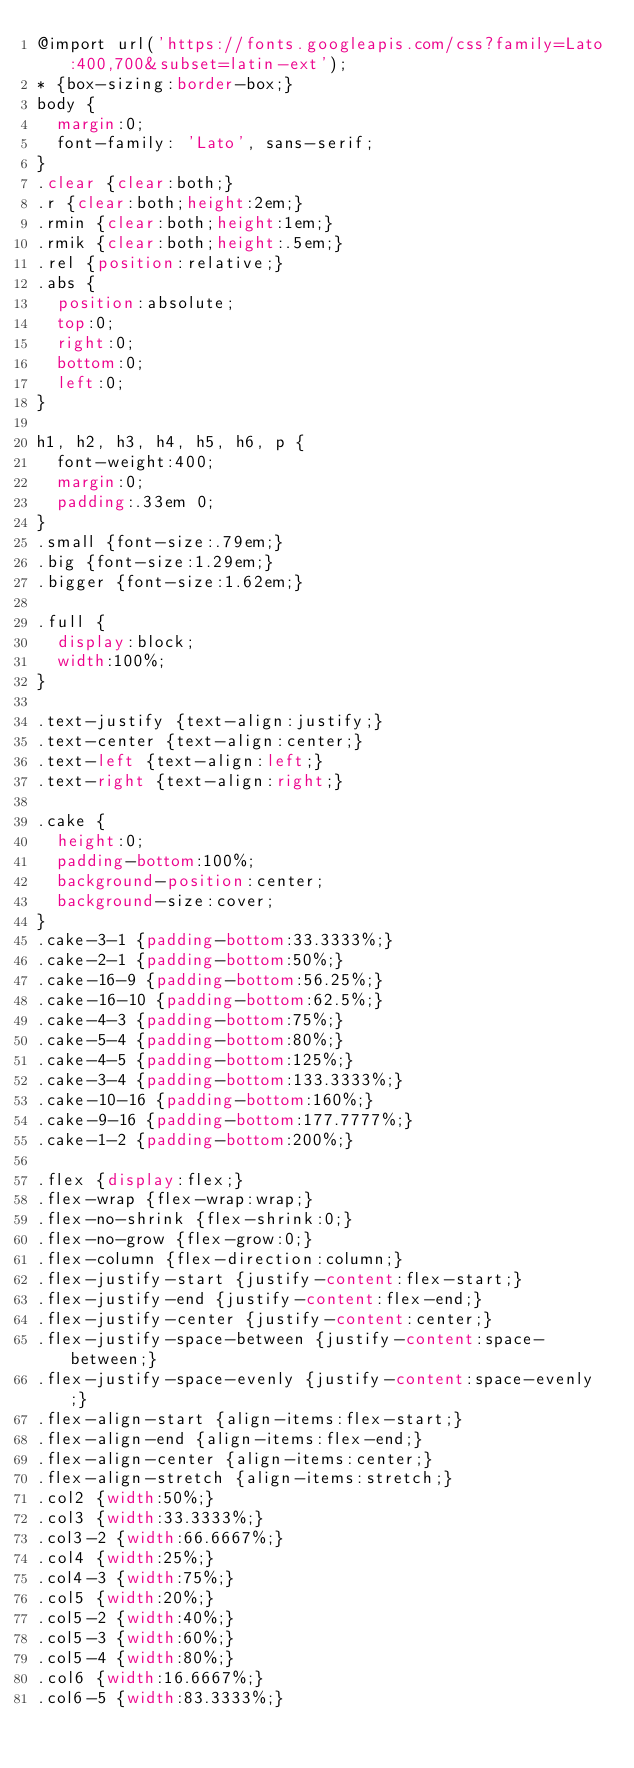Convert code to text. <code><loc_0><loc_0><loc_500><loc_500><_CSS_>@import url('https://fonts.googleapis.com/css?family=Lato:400,700&subset=latin-ext');
* {box-sizing:border-box;}
body {
	margin:0;
	font-family: 'Lato', sans-serif;
}
.clear {clear:both;}
.r {clear:both;height:2em;}
.rmin {clear:both;height:1em;}
.rmik {clear:both;height:.5em;}
.rel {position:relative;}
.abs {
  position:absolute;
  top:0;
  right:0;
  bottom:0;
  left:0;
}

h1, h2, h3, h4, h5, h6, p {
  font-weight:400;
  margin:0;
  padding:.33em 0;
}
.small {font-size:.79em;}
.big {font-size:1.29em;}
.bigger {font-size:1.62em;}

.full {
  display:block;
  width:100%;
}

.text-justify {text-align:justify;}
.text-center {text-align:center;}
.text-left {text-align:left;}
.text-right {text-align:right;}

.cake {
  height:0;
  padding-bottom:100%;
  background-position:center;
  background-size:cover;
}
.cake-3-1 {padding-bottom:33.3333%;}
.cake-2-1 {padding-bottom:50%;}
.cake-16-9 {padding-bottom:56.25%;}
.cake-16-10 {padding-bottom:62.5%;}
.cake-4-3 {padding-bottom:75%;}
.cake-5-4 {padding-bottom:80%;}
.cake-4-5 {padding-bottom:125%;}
.cake-3-4 {padding-bottom:133.3333%;}
.cake-10-16 {padding-bottom:160%;}
.cake-9-16 {padding-bottom:177.7777%;}
.cake-1-2 {padding-bottom:200%;}

.flex {display:flex;}
.flex-wrap {flex-wrap:wrap;}
.flex-no-shrink {flex-shrink:0;}
.flex-no-grow {flex-grow:0;}
.flex-column {flex-direction:column;}
.flex-justify-start {justify-content:flex-start;}
.flex-justify-end {justify-content:flex-end;}
.flex-justify-center {justify-content:center;}
.flex-justify-space-between {justify-content:space-between;}
.flex-justify-space-evenly {justify-content:space-evenly;}
.flex-align-start {align-items:flex-start;}
.flex-align-end {align-items:flex-end;}
.flex-align-center {align-items:center;}
.flex-align-stretch {align-items:stretch;}
.col2 {width:50%;}
.col3 {width:33.3333%;}
.col3-2 {width:66.6667%;}
.col4 {width:25%;}
.col4-3 {width:75%;}
.col5 {width:20%;}
.col5-2 {width:40%;}
.col5-3 {width:60%;}
.col5-4 {width:80%;}
.col6 {width:16.6667%;}
.col6-5 {width:83.3333%;}</code> 